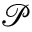Convert formula to latex. <formula><loc_0><loc_0><loc_500><loc_500>\mathcal { P }</formula> 